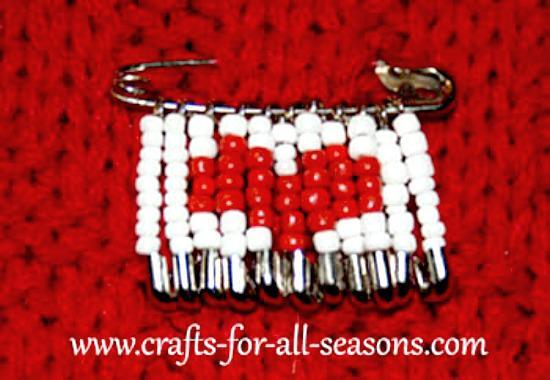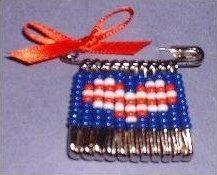The first image is the image on the left, the second image is the image on the right. Examine the images to the left and right. Is the description "There is a heart pattern made of beads in at least one of the images." accurate? Answer yes or no. Yes. The first image is the image on the left, the second image is the image on the right. For the images displayed, is the sentence "One safety pin jewelry item features a heart design using red, white, and blue beads." factually correct? Answer yes or no. Yes. 